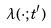<formula> <loc_0><loc_0><loc_500><loc_500>\lambda ( \cdot ; t ^ { \prime } )</formula> 